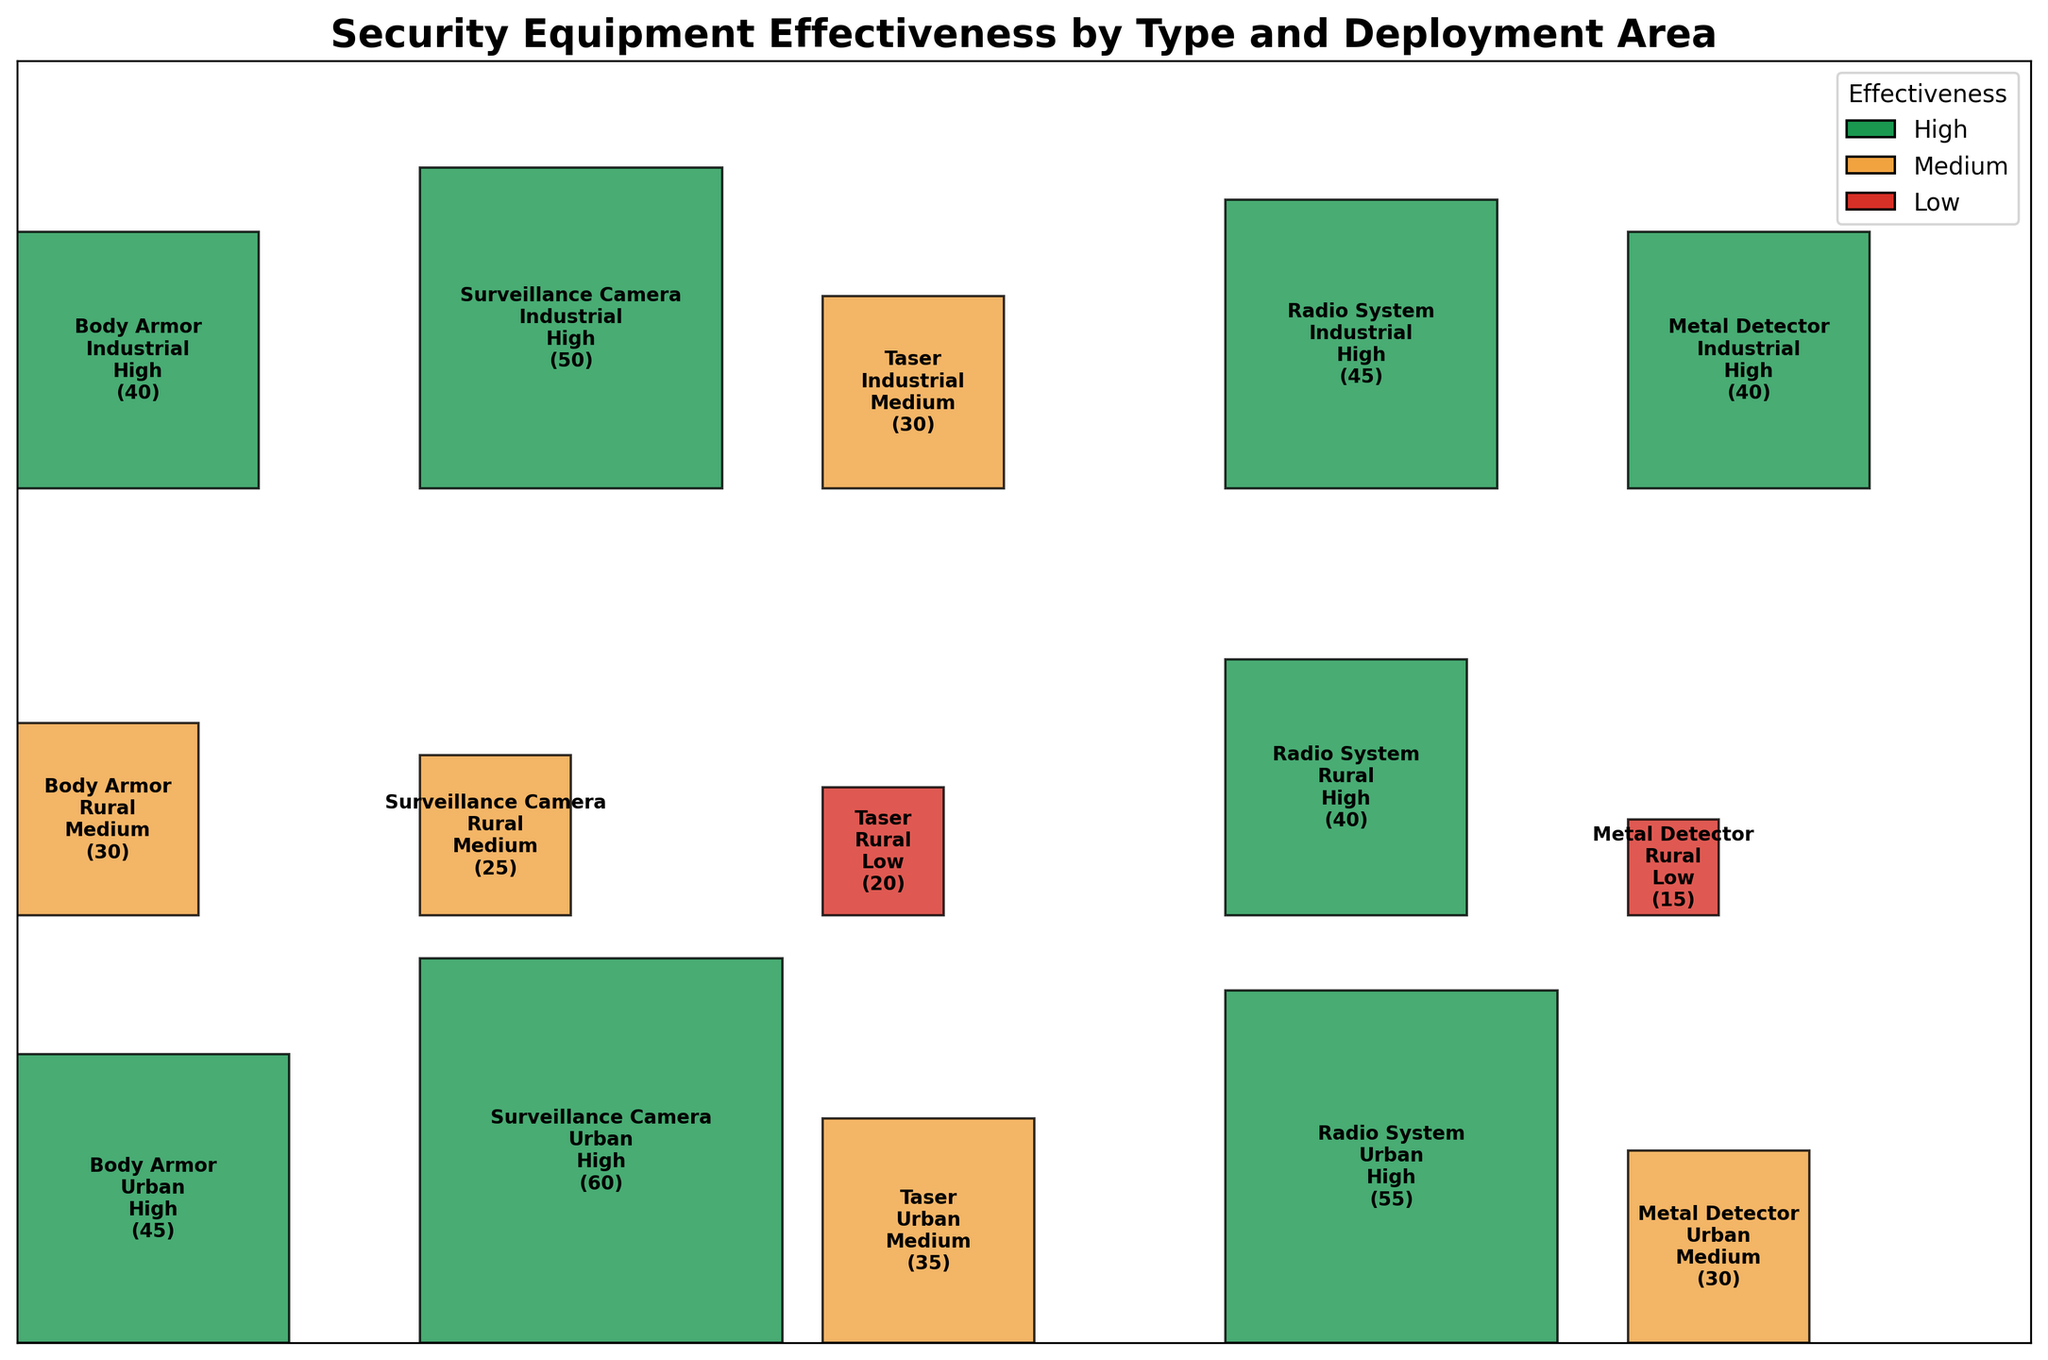What is the title of the plot? The title of the plot is located at the top of the figure and is written in bold, larger font for emphasis.
Answer: Security Equipment Effectiveness by Type and Deployment Area Which effectiveness level is indicated by the color green? The legend on the plot assigns different colors to the effectiveness levels. The green colored rectangles represent the 'High' effectiveness level.
Answer: High How many pieces of body armor were counted in the Rural area? The text inside the rectangle corresponding to Body Armor in the Rural area displays "(30)". This is the count of pieces of body armor in that deployment area.
Answer: 30 Which deployment area has the highest number of Surveillance Cameras rated as 'High' effectiveness? By examining the rectangles labeled 'Surveillance Camera' and colored green (indicating 'High' effectiveness), we can see that the Urban area has a count of 60, which is the highest among deployment areas.
Answer: Urban Are Tasers more effective in Urban or Rural areas based on their effectiveness levels? We need to compare the effectiveness levels for the Urban and Rural areas. The Urban area has Tasers rated as 'Medium' effectiveness, while the Rural area has them rated as 'Low' effectiveness. Thus, Tasers are more effective in urban areas.
Answer: Urban In which deployment area is the effectiveness level of Metal Detectors 'Low'? The color red in the plot indicates a 'Low' effectiveness level. The rectangle for Metal Detectors in the Rural area is colored red, thus the effectiveness level is Low there.
Answer: Rural What is the sum of the counts of all equipment deemed 'High' effectiveness in Industrial areas? We sum the counts of all 'High' effectiveness equipment in the Industrial area: Body Armor (40), Surveillance Camera (50), Radio System (45), and Metal Detector (40). This equals 40 + 50 + 45 + 40 = 175.
Answer: 175 Is there any equipment type that has a 'High' effectiveness level in all deployment areas? By checking each equipment type, we find that the Radio System has 'High' effectiveness in Urban, Rural, and Industrial areas as indicated by green-colored rectangles.
Answer: Yes Compare the effectiveness of Radio Systems and Metal Detectors in Urban areas. Which one is more effective? Both Radio Systems and Metal Detectors in the Urban area are marked with the 'High' effectiveness (green color), indicating they are equally effective.
Answer: Equally effective 